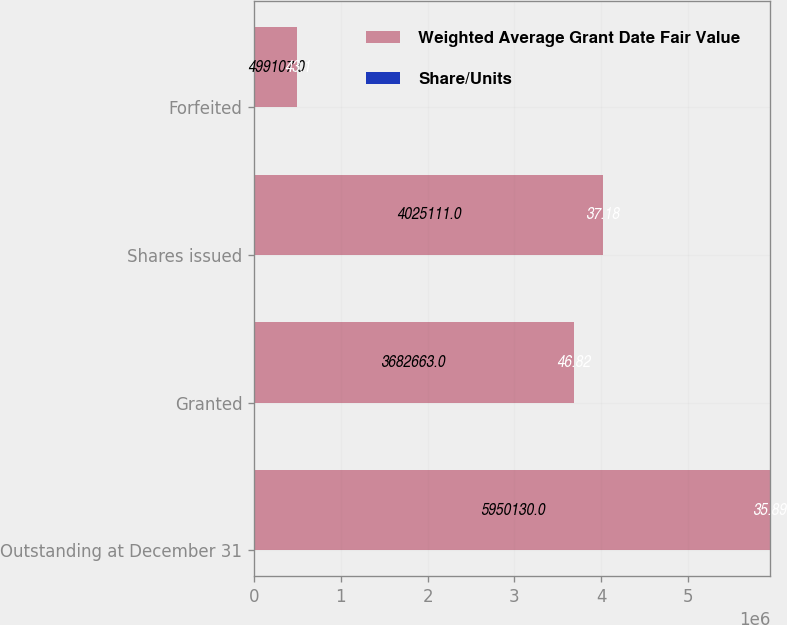Convert chart. <chart><loc_0><loc_0><loc_500><loc_500><stacked_bar_chart><ecel><fcel>Outstanding at December 31<fcel>Granted<fcel>Shares issued<fcel>Forfeited<nl><fcel>Weighted Average Grant Date Fair Value<fcel>5.95013e+06<fcel>3.68266e+06<fcel>4.02511e+06<fcel>499107<nl><fcel>Share/Units<fcel>35.89<fcel>46.82<fcel>37.18<fcel>43.1<nl></chart> 